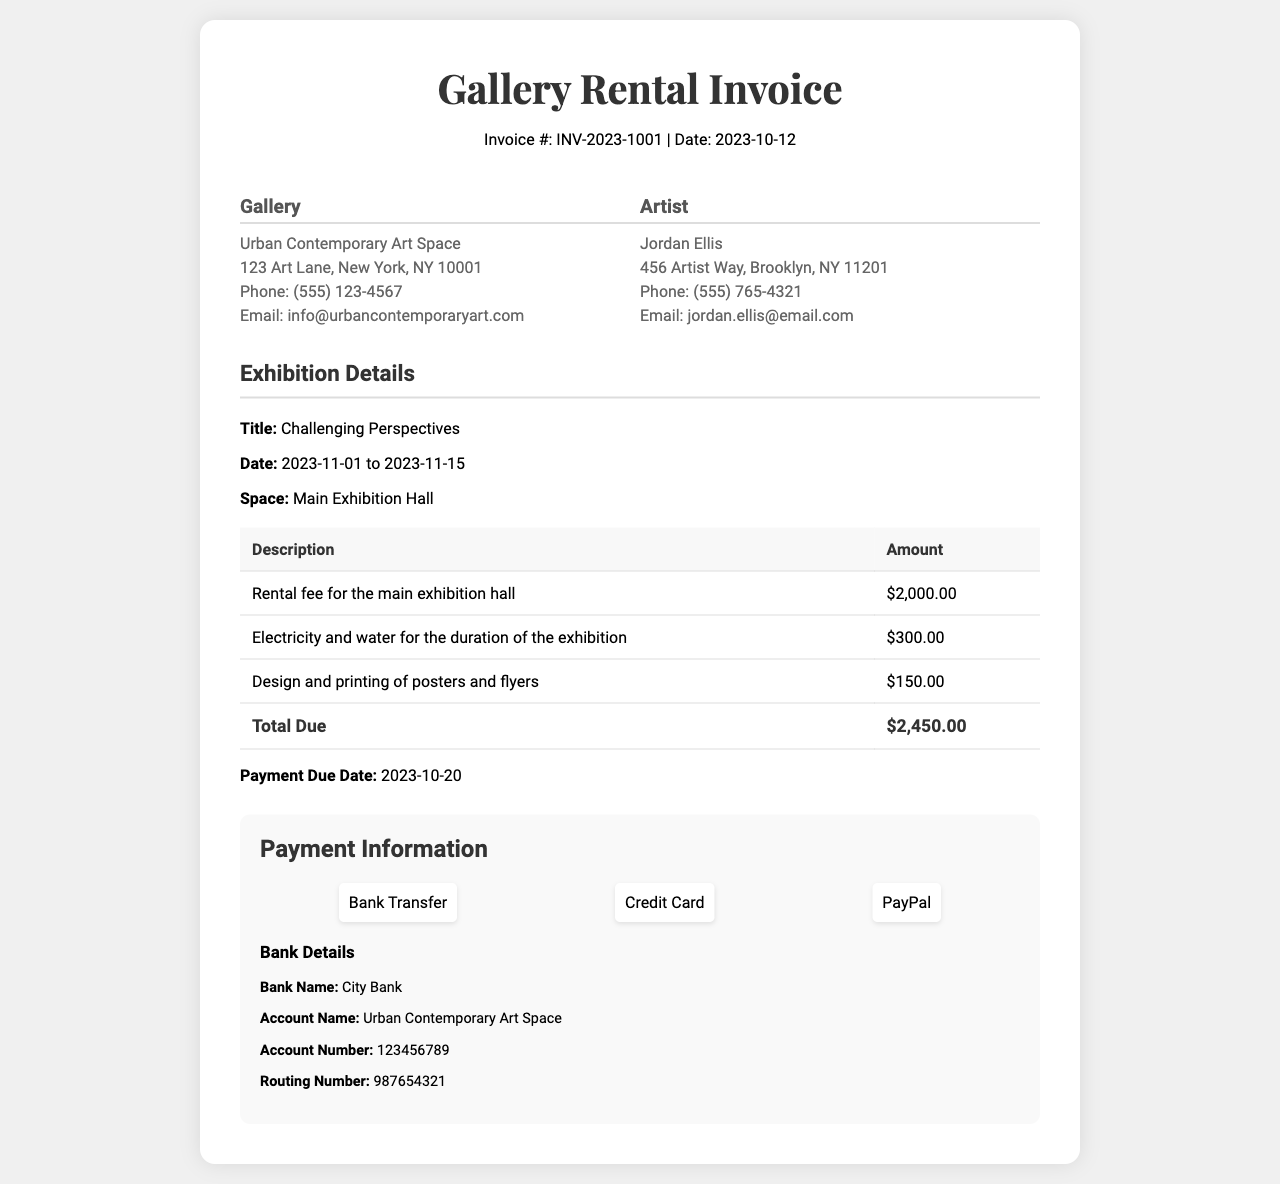What is the invoice number? The invoice number is listed at the top of the document, specified as INV-2023-1001.
Answer: INV-2023-1001 Who is the artist? The artist's name is provided in the artist information section, which states Jordan Ellis.
Answer: Jordan Ellis What is the total amount due? The total amount due is calculated from the charges listed in the table, with a final total of $2,450.00.
Answer: $2,450.00 What is the payment due date? The payment due date is specified in the rental details as October 20, 2023.
Answer: 2023-10-20 What is the rental fee for the main exhibition hall? The rental fee for the main exhibition hall is detailed in the table as $2,000.00.
Answer: $2,000.00 How long is the exhibition scheduled to run? The exhibition is set to run from November 1 to November 15, 2023, as indicated in the details.
Answer: 2023-11-01 to 2023-11-15 What method of payment is accepted? The document lists the available payment methods, including bank transfer, credit card, and PayPal.
Answer: Bank Transfer, Credit Card, PayPal What is the gallery's address? The gallery's address is included in the gallery information, listed as 123 Art Lane, New York, NY 10001.
Answer: 123 Art Lane, New York, NY 10001 What is the description of the promotional materials cost? The descriptive charge for promotional materials indicates the design and printing of posters and flyers costing $150.00.
Answer: Design and printing of posters and flyers What is the gallery's email address? The gallery's contact email is provided in the gallery information section as info@urbancontemporaryart.com.
Answer: info@urbancontemporaryart.com 